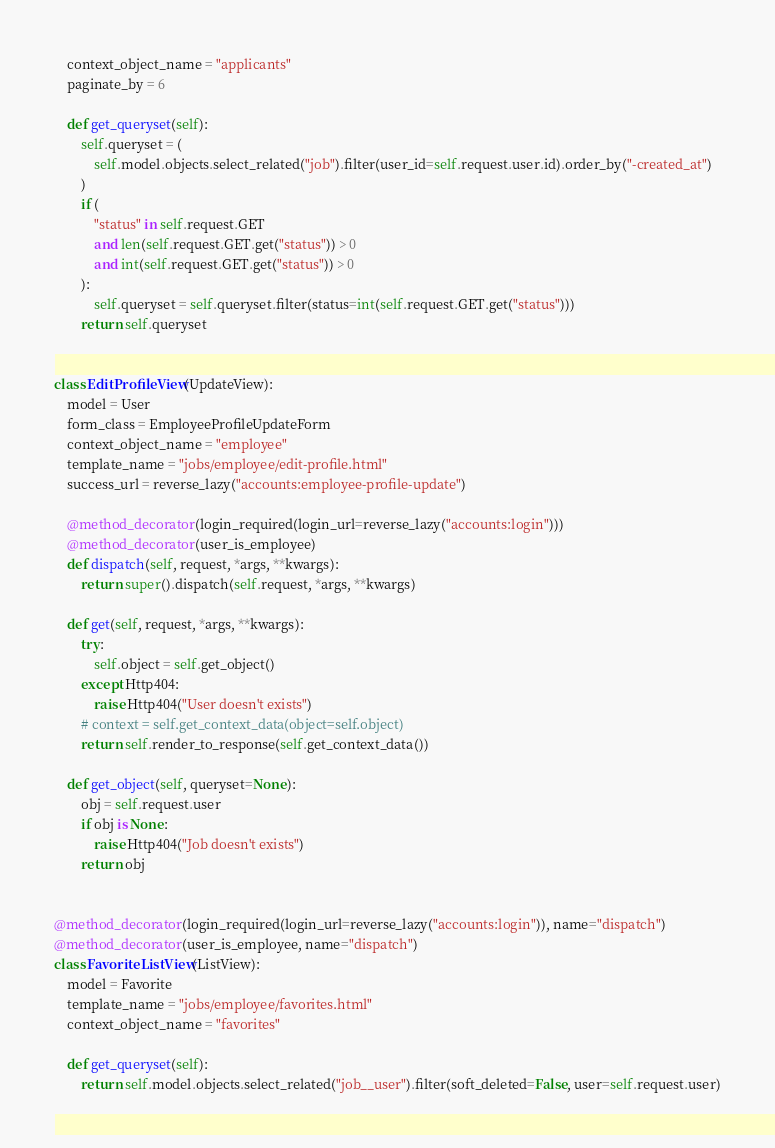<code> <loc_0><loc_0><loc_500><loc_500><_Python_>    context_object_name = "applicants"
    paginate_by = 6

    def get_queryset(self):
        self.queryset = (
            self.model.objects.select_related("job").filter(user_id=self.request.user.id).order_by("-created_at")
        )
        if (
            "status" in self.request.GET
            and len(self.request.GET.get("status")) > 0
            and int(self.request.GET.get("status")) > 0
        ):
            self.queryset = self.queryset.filter(status=int(self.request.GET.get("status")))
        return self.queryset


class EditProfileView(UpdateView):
    model = User
    form_class = EmployeeProfileUpdateForm
    context_object_name = "employee"
    template_name = "jobs/employee/edit-profile.html"
    success_url = reverse_lazy("accounts:employee-profile-update")

    @method_decorator(login_required(login_url=reverse_lazy("accounts:login")))
    @method_decorator(user_is_employee)
    def dispatch(self, request, *args, **kwargs):
        return super().dispatch(self.request, *args, **kwargs)

    def get(self, request, *args, **kwargs):
        try:
            self.object = self.get_object()
        except Http404:
            raise Http404("User doesn't exists")
        # context = self.get_context_data(object=self.object)
        return self.render_to_response(self.get_context_data())

    def get_object(self, queryset=None):
        obj = self.request.user
        if obj is None:
            raise Http404("Job doesn't exists")
        return obj


@method_decorator(login_required(login_url=reverse_lazy("accounts:login")), name="dispatch")
@method_decorator(user_is_employee, name="dispatch")
class FavoriteListView(ListView):
    model = Favorite
    template_name = "jobs/employee/favorites.html"
    context_object_name = "favorites"

    def get_queryset(self):
        return self.model.objects.select_related("job__user").filter(soft_deleted=False, user=self.request.user)

</code> 